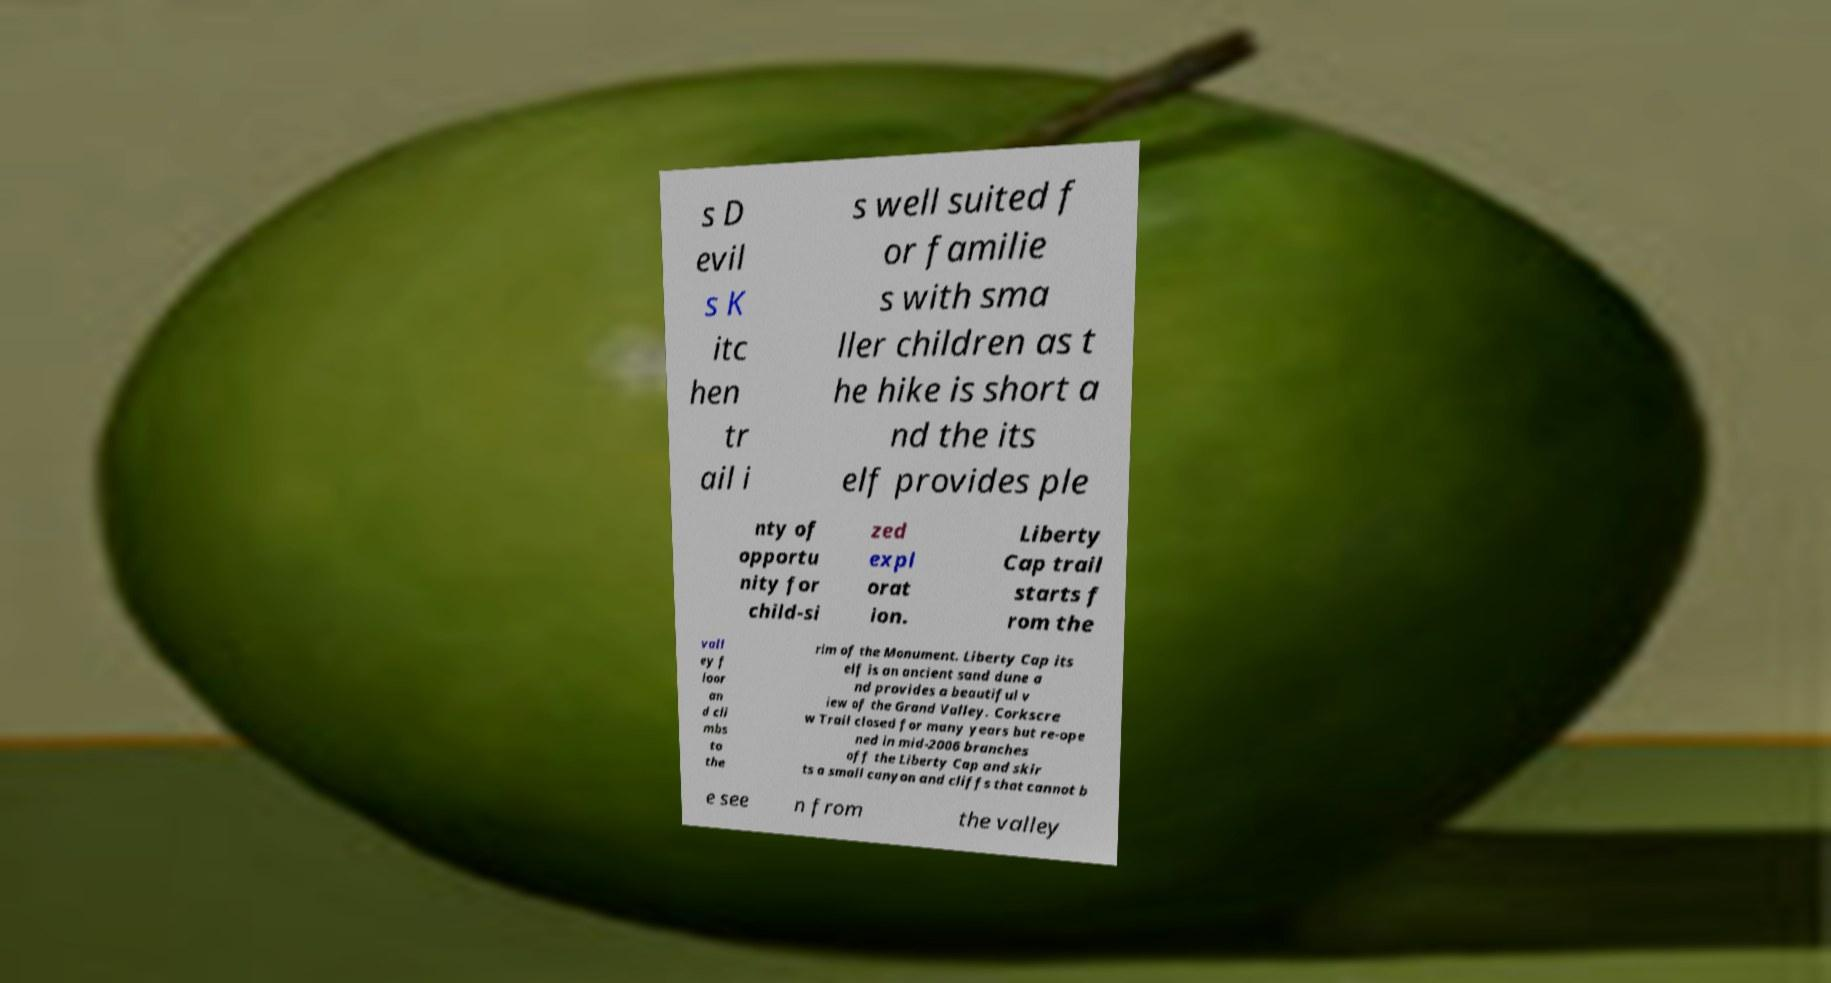Can you accurately transcribe the text from the provided image for me? s D evil s K itc hen tr ail i s well suited f or familie s with sma ller children as t he hike is short a nd the its elf provides ple nty of opportu nity for child-si zed expl orat ion. Liberty Cap trail starts f rom the vall ey f loor an d cli mbs to the rim of the Monument. Liberty Cap its elf is an ancient sand dune a nd provides a beautiful v iew of the Grand Valley. Corkscre w Trail closed for many years but re-ope ned in mid-2006 branches off the Liberty Cap and skir ts a small canyon and cliffs that cannot b e see n from the valley 